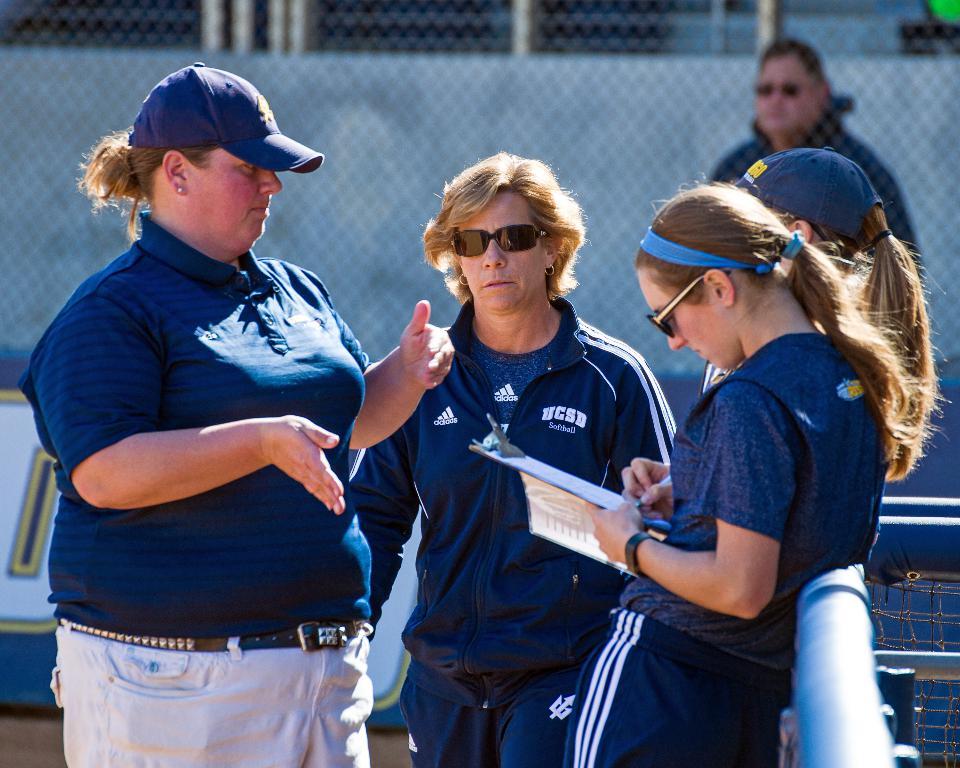Are they from the softball team?
Give a very brief answer. Yes. What school do they play for?
Provide a succinct answer. Ucsd. 